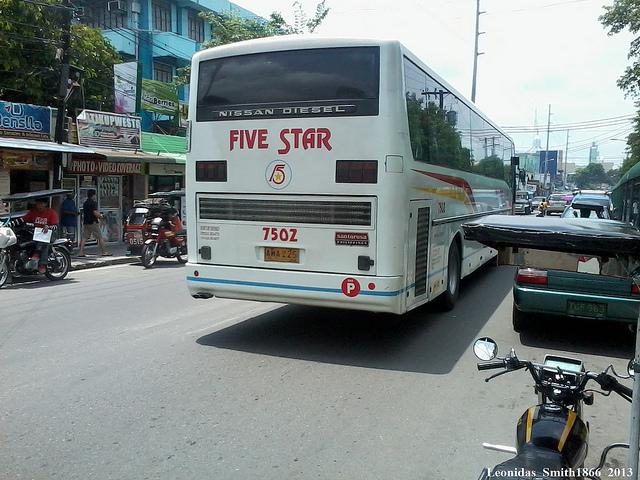Who is sitting on the motorbike?
Keep it brief. No one. Is this a tour bus?
Quick response, please. Yes. What is the make of the bus?
Keep it brief. Five star. What is the vehicle's license plate number?
Answer briefly. 7502. Do you see any mountains in the picture?
Answer briefly. No. Are the words on the bus in English?
Give a very brief answer. Yes. What does the bus read on it's rear?
Quick response, please. Five star. Is this street one direction?
Be succinct. No. What color is the bus?
Write a very short answer. White. Is the sun setting?
Write a very short answer. No. What numbers are in red?
Give a very brief answer. 7502. Is there a satellite in the photo?
Write a very short answer. No. 